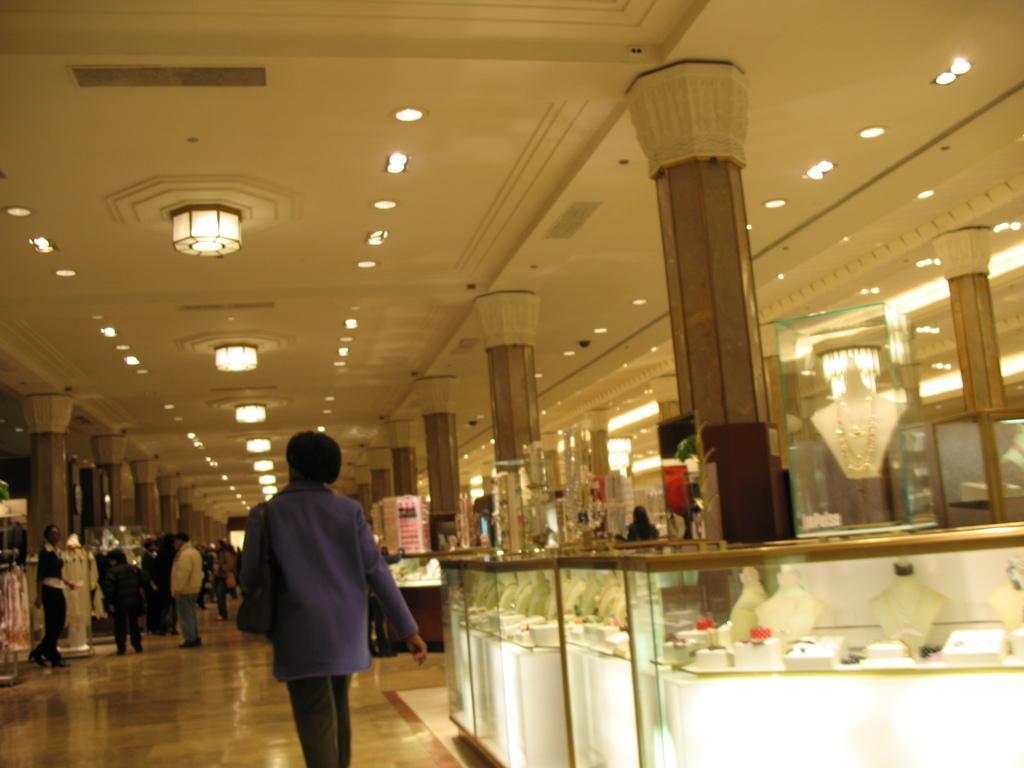Please provide a concise description of this image. In this picture I can observe some people standing on the floor. On the right side I can observe jewellery placed in the shelf. I can observe lights fixed to the ceiling. 